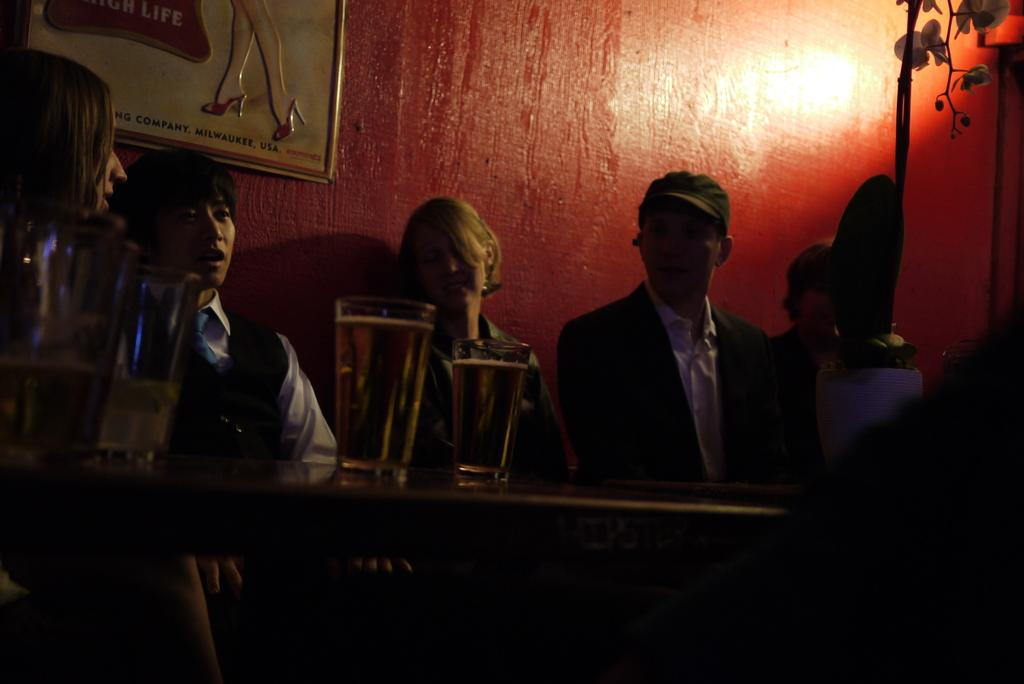How many people are in the image? There is a group of people in the image. What are the people doing in the image? The people are sitting on chairs. What can be seen on the table in the image? There is a glass on a table in the image. What is hanging on the wall in the image? There is a frame on a wall in the image. What type of vegetation is present in the image? There is a plant in the image. What type of trouble is the sidewalk causing in the image? There is no sidewalk present in the image, so it cannot cause any trouble. 